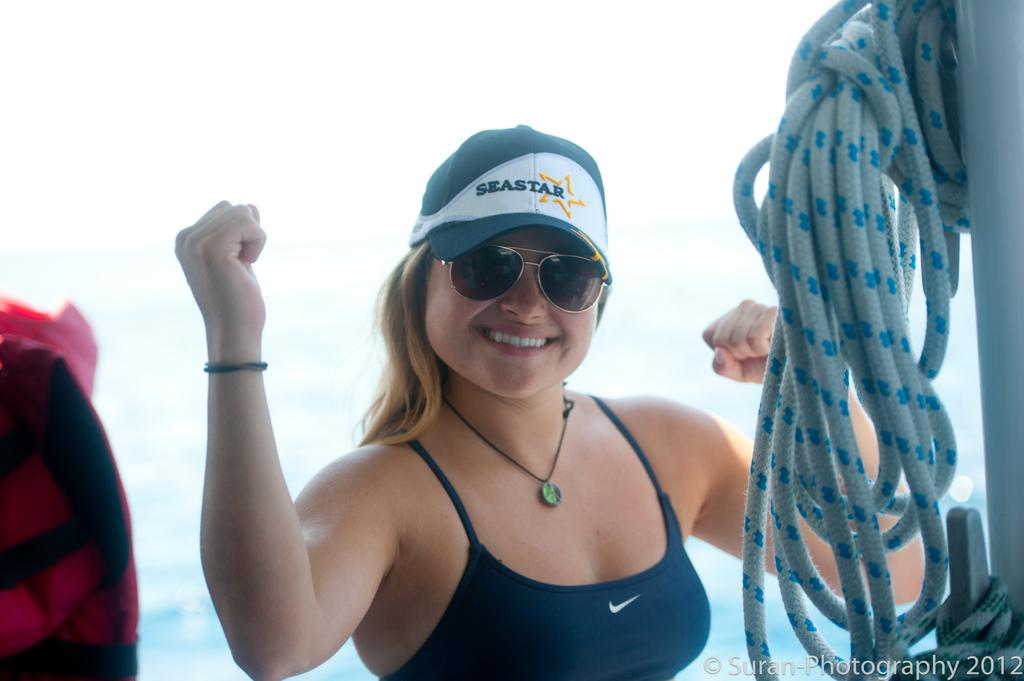What is the woman doing in the image? The woman is standing in the image. What expression does the woman have? The woman is smiling. What can be seen in the background of the image? Sky and water are visible in the image. What object is connected to a pole in the image? There is a rope hanged to a pole in the image. What is the name of the snake that is slithering through the water in the image? There is no snake present in the image; it only features a woman standing, a smiling expression, sky, water, and a rope hanged to a pole. 